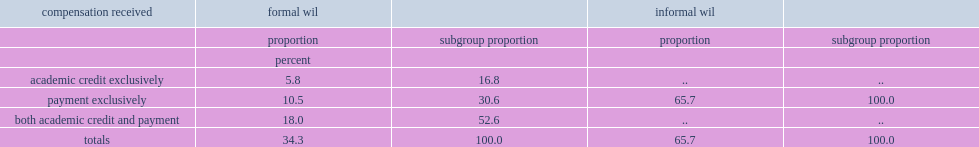Could you parse the entire table? {'header': ['compensation received', 'formal wil', '', 'informal wil', ''], 'rows': [['', 'proportion', 'subgroup proportion', 'proportion', 'subgroup proportion'], ['', 'percent', '', '', ''], ['academic credit exclusively', '5.8', '16.8', '..', '..'], ['payment exclusively', '10.5', '30.6', '65.7', '100.0'], ['both academic credit and payment', '18.0', '52.6', '..', '..'], ['totals', '34.3', '100.0', '65.7', '100.0']]} What was the percentage of those who received both academic credit and payment? 52.6. What were the percentages of those receiving academic credit exclusively and receiving payment exclusively respectively? 16.8 30.6. 